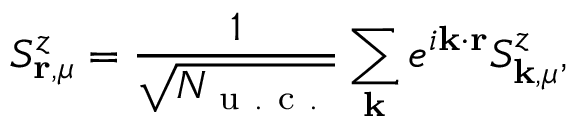<formula> <loc_0><loc_0><loc_500><loc_500>S _ { r , \mu } ^ { z } = \frac { 1 } { \sqrt { N _ { u . c . } } } \sum _ { k } e ^ { i k \cdot r } S _ { k , \mu } ^ { z } ,</formula> 